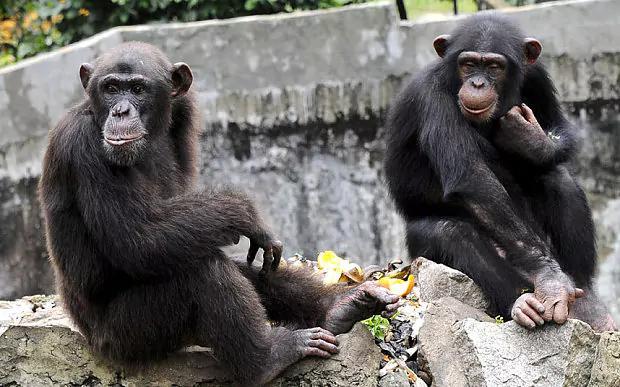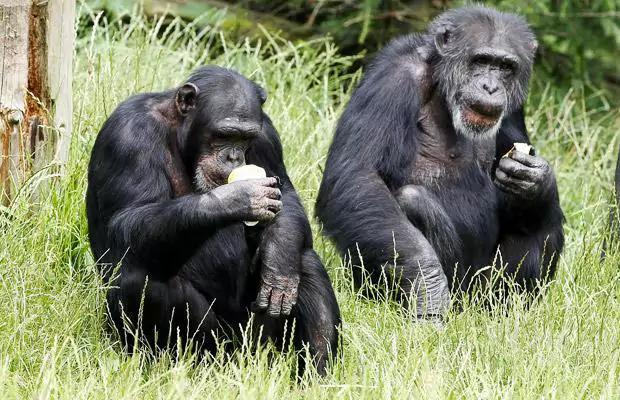The first image is the image on the left, the second image is the image on the right. Given the left and right images, does the statement "The apes are hugging each other in both pictures." hold true? Answer yes or no. No. The first image is the image on the left, the second image is the image on the right. Considering the images on both sides, is "chimps are hugging each other in both image pairs" valid? Answer yes or no. No. 